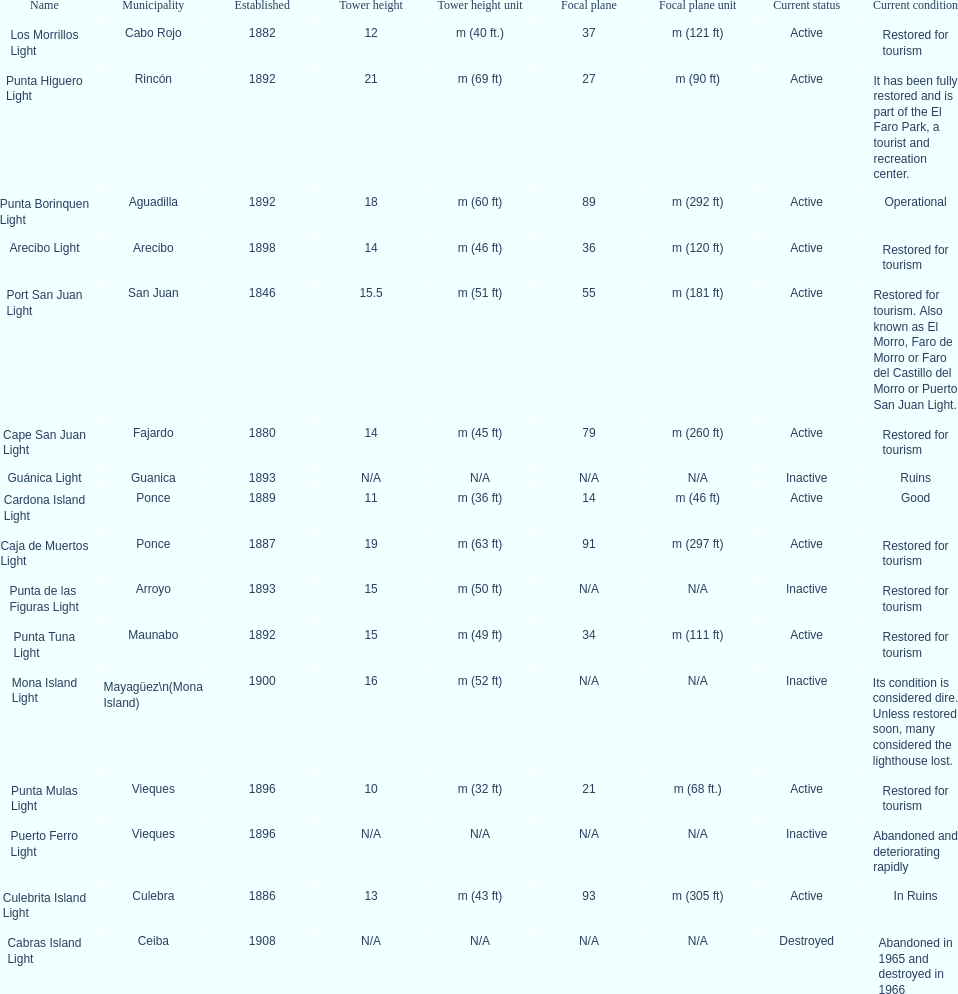Could you help me parse every detail presented in this table? {'header': ['Name', 'Municipality', 'Established', 'Tower height', 'Tower height unit', 'Focal plane', 'Focal plane unit', 'Current status', 'Current condition'], 'rows': [['Los Morrillos Light', 'Cabo Rojo', '1882', '12', 'm (40 ft.)', '37', 'm (121 ft)', 'Active', 'Restored for tourism'], ['Punta Higuero Light', 'Rincón', '1892', '21', 'm (69 ft)', '27', 'm (90 ft)', 'Active', 'It has been fully restored and is part of the El Faro Park, a tourist and recreation center.'], ['Punta Borinquen Light', 'Aguadilla', '1892', '18', 'm (60 ft)', '89', 'm (292 ft)', 'Active', 'Operational'], ['Arecibo Light', 'Arecibo', '1898', '14', 'm (46 ft)', '36', 'm (120 ft)', 'Active', 'Restored for tourism'], ['Port San Juan Light', 'San Juan', '1846', '15.5', 'm (51 ft)', '55', 'm (181 ft)', 'Active', 'Restored for tourism. Also known as El Morro, Faro de Morro or Faro del Castillo del Morro or Puerto San Juan Light.'], ['Cape San Juan Light', 'Fajardo', '1880', '14', 'm (45 ft)', '79', 'm (260 ft)', 'Active', 'Restored for tourism'], ['Guánica Light', 'Guanica', '1893', 'N/A', 'N/A', 'N/A', 'N/A', 'Inactive', 'Ruins'], ['Cardona Island Light', 'Ponce', '1889', '11', 'm (36 ft)', '14', 'm (46 ft)', 'Active', 'Good'], ['Caja de Muertos Light', 'Ponce', '1887', '19', 'm (63 ft)', '91', 'm (297 ft)', 'Active', 'Restored for tourism'], ['Punta de las Figuras Light', 'Arroyo', '1893', '15', 'm (50 ft)', 'N/A', 'N/A', 'Inactive', 'Restored for tourism'], ['Punta Tuna Light', 'Maunabo', '1892', '15', 'm (49 ft)', '34', 'm (111 ft)', 'Active', 'Restored for tourism'], ['Mona Island Light', 'Mayagüez\\n(Mona Island)', '1900', '16', 'm (52 ft)', 'N/A', 'N/A', 'Inactive', 'Its condition is considered dire. Unless restored soon, many considered the lighthouse lost.'], ['Punta Mulas Light', 'Vieques', '1896', '10', 'm (32 ft)', '21', 'm (68 ft.)', 'Active', 'Restored for tourism'], ['Puerto Ferro Light', 'Vieques', '1896', 'N/A', 'N/A', 'N/A', 'N/A', 'Inactive', 'Abandoned and deteriorating rapidly'], ['Culebrita Island Light', 'Culebra', '1886', '13', 'm (43 ft)', '93', 'm (305 ft)', 'Active', 'In Ruins'], ['Cabras Island Light', 'Ceiba', '1908', 'N/A', 'N/A', 'N/A', 'N/A', 'Destroyed', 'Abandoned in 1965 and destroyed in 1966']]} Names of municipalities established before 1880 San Juan. 